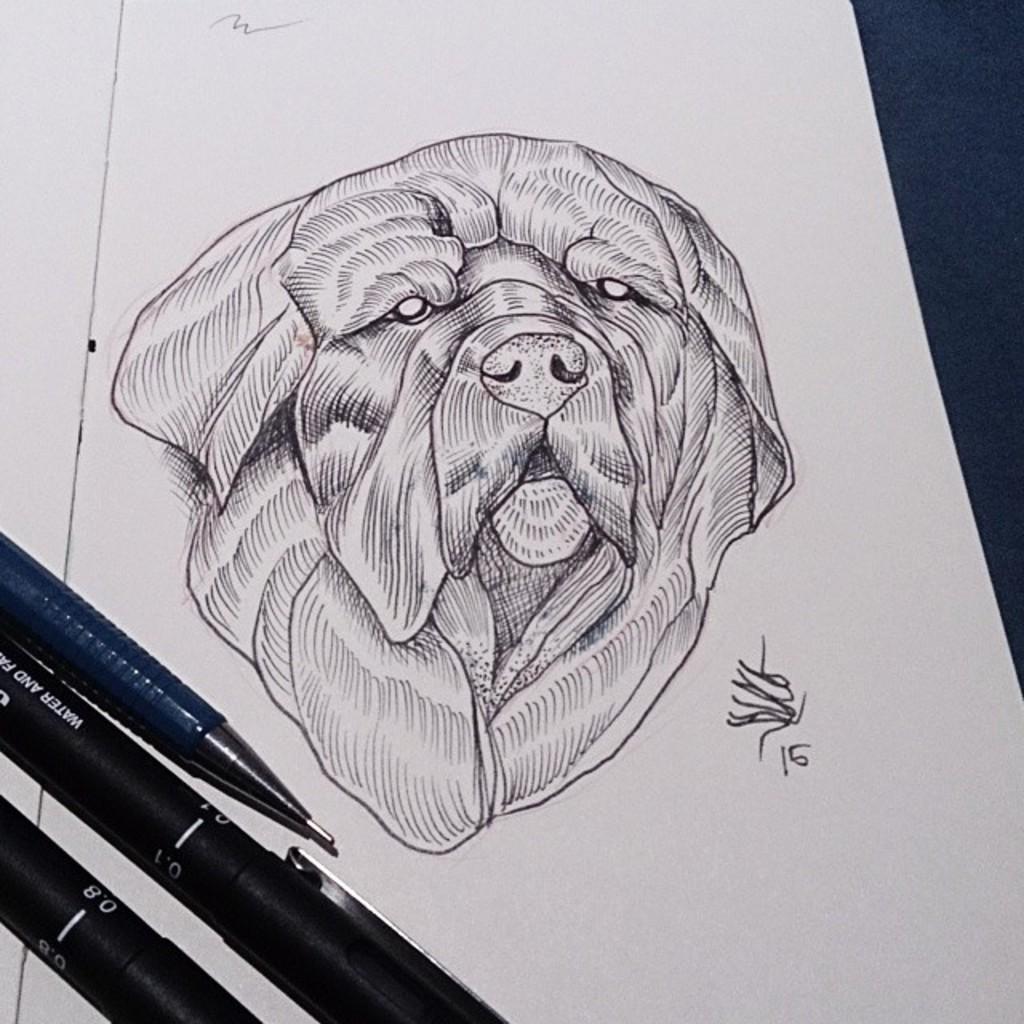How would you summarize this image in a sentence or two? In this image we can see a drawing of a dog on the paper. There are pens. 